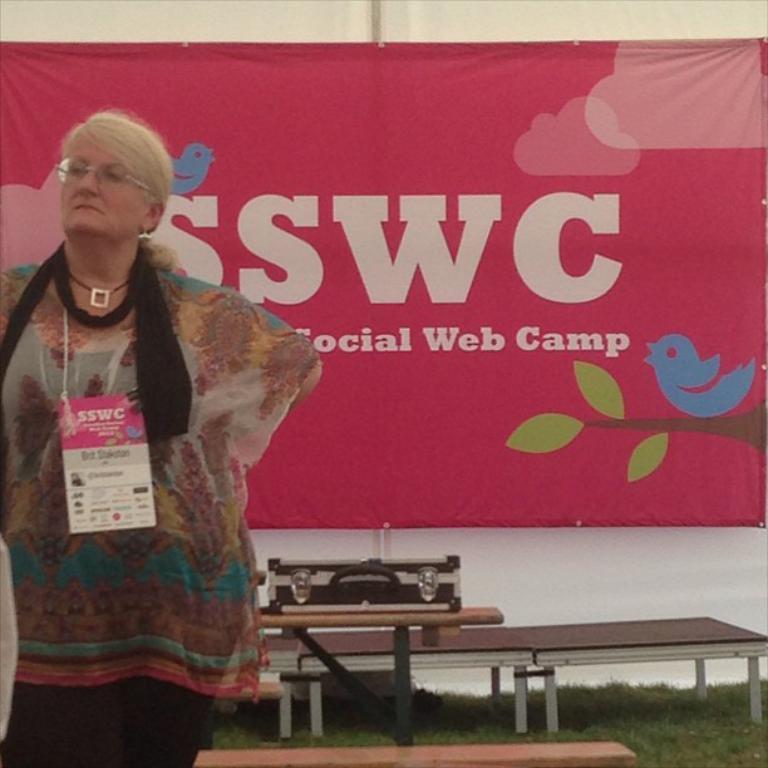In one or two sentences, can you explain what this image depicts? In this image I can see on the left side a woman is standing, she wore dress and also an Id card in pink color behind her there is a back ground cloth in pink color. At the bottom there are benches on the grass. 